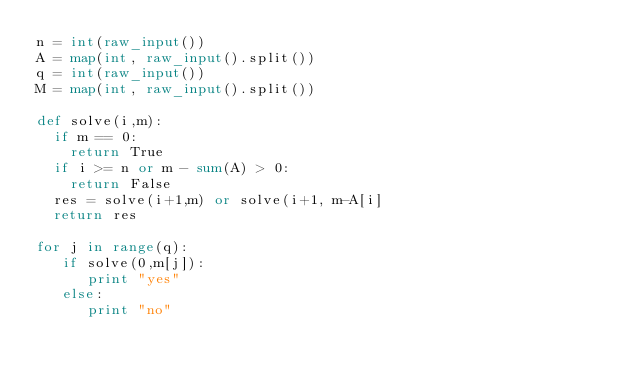<code> <loc_0><loc_0><loc_500><loc_500><_Python_>n = int(raw_input())
A = map(int, raw_input().split())
q = int(raw_input())
M = map(int, raw_input().split())
  
def solve(i,m):
  if m == 0:
    return True
  if i >= n or m - sum(A) > 0:
    return False
  res = solve(i+1,m) or solve(i+1, m-A[i]
  return res

for j in range(q):
   if solve(0,m[j]):
      print "yes"
   else:
      print "no"
 </code> 